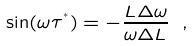<formula> <loc_0><loc_0><loc_500><loc_500>\sin ( \omega \tau ^ { ^ { * } } ) = - \frac { L \Delta \omega } { \omega \Delta L } \ ,</formula> 